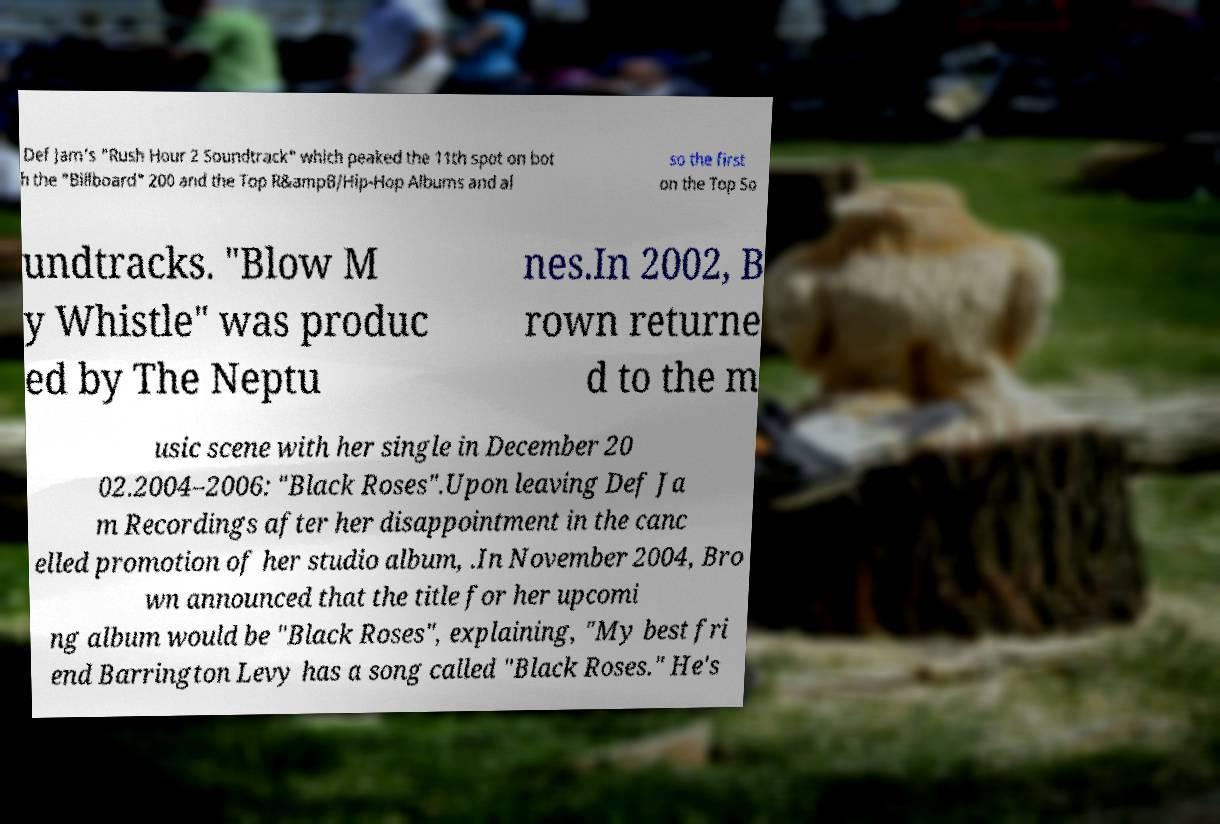Can you read and provide the text displayed in the image?This photo seems to have some interesting text. Can you extract and type it out for me? Def Jam's "Rush Hour 2 Soundtrack" which peaked the 11th spot on bot h the "Billboard" 200 and the Top R&ampB/Hip-Hop Albums and al so the first on the Top So undtracks. "Blow M y Whistle" was produc ed by The Neptu nes.In 2002, B rown returne d to the m usic scene with her single in December 20 02.2004–2006: "Black Roses".Upon leaving Def Ja m Recordings after her disappointment in the canc elled promotion of her studio album, .In November 2004, Bro wn announced that the title for her upcomi ng album would be "Black Roses", explaining, "My best fri end Barrington Levy has a song called "Black Roses." He's 